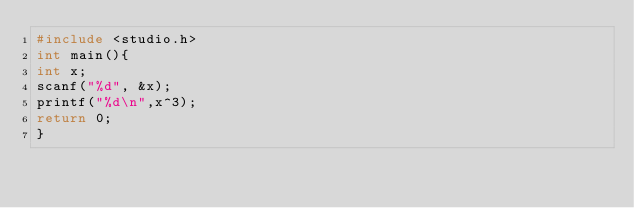<code> <loc_0><loc_0><loc_500><loc_500><_C_>#include <studio.h>
int main(){
int x;
scanf("%d", &x);
printf("%d\n",x^3);
return 0;
}</code> 